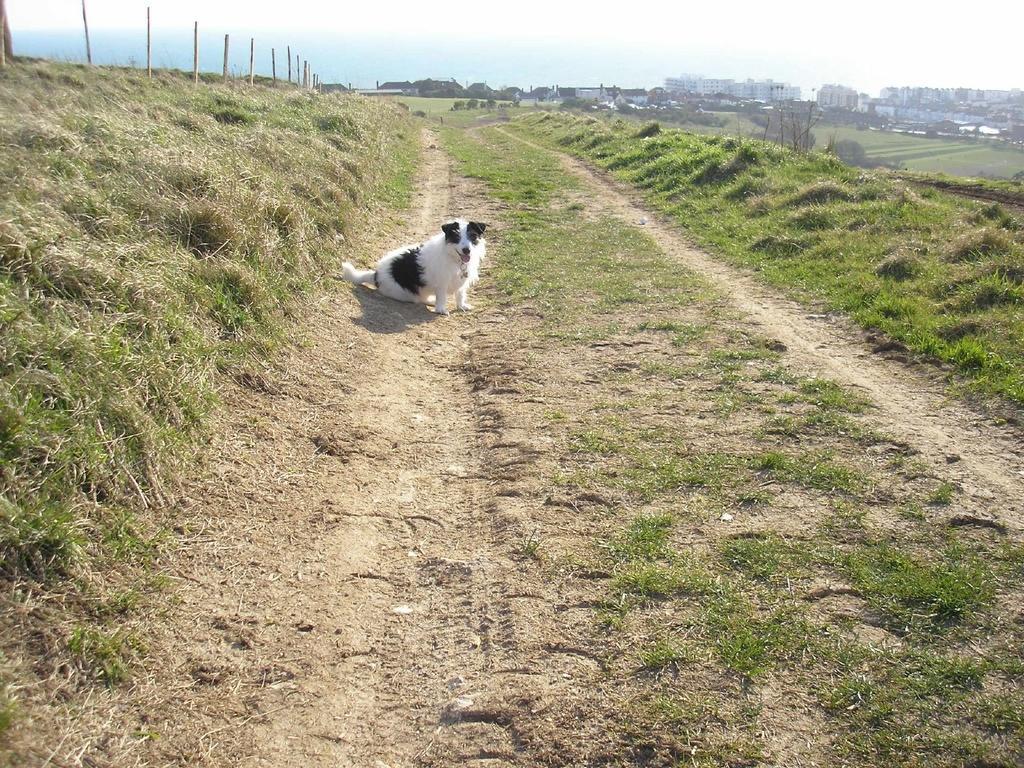Could you give a brief overview of what you see in this image? In this picture we can see a dog on the path. In the top right corner of the image, there are buildings, trees and the sky. In the top left corner of the image, there are poles and grass. 